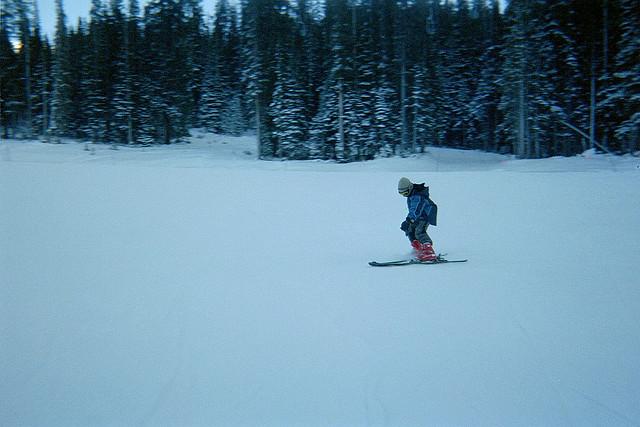What is the white stuff on the trees?
Give a very brief answer. Snow. What is on the man's feet?
Keep it brief. Skis. What is this person doing?
Keep it brief. Skiing. 